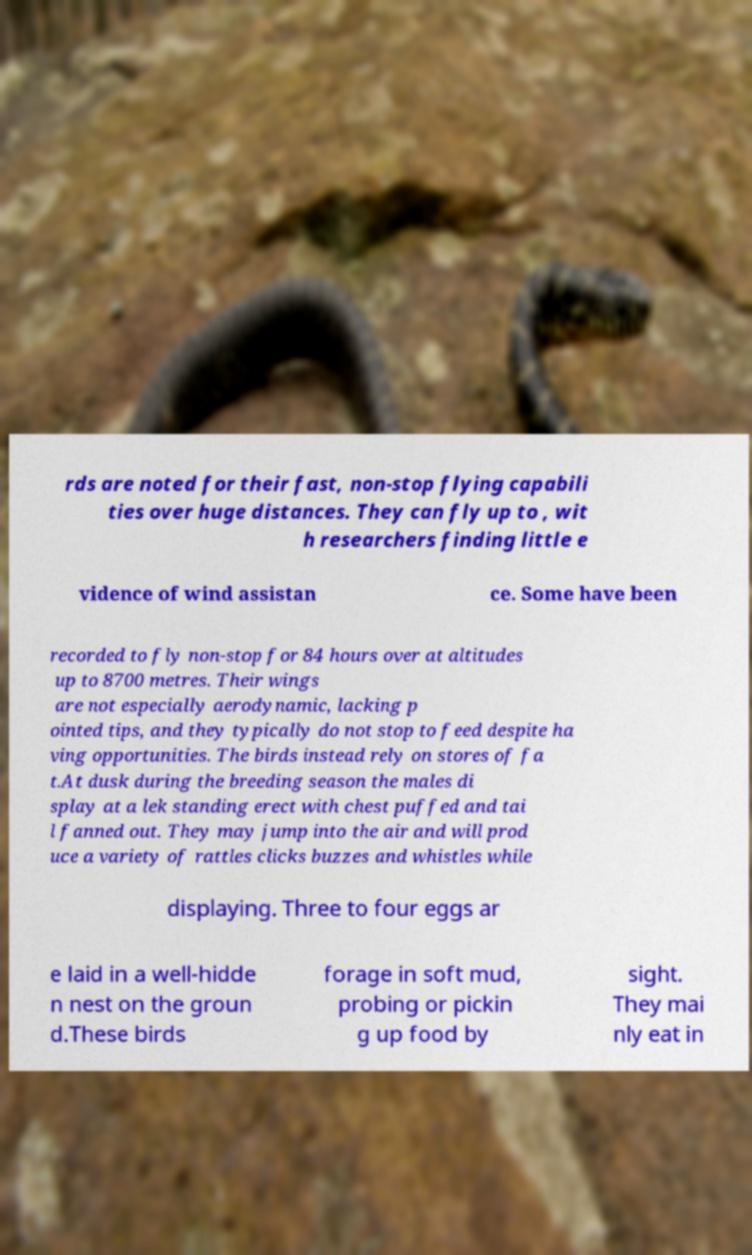There's text embedded in this image that I need extracted. Can you transcribe it verbatim? rds are noted for their fast, non-stop flying capabili ties over huge distances. They can fly up to , wit h researchers finding little e vidence of wind assistan ce. Some have been recorded to fly non-stop for 84 hours over at altitudes up to 8700 metres. Their wings are not especially aerodynamic, lacking p ointed tips, and they typically do not stop to feed despite ha ving opportunities. The birds instead rely on stores of fa t.At dusk during the breeding season the males di splay at a lek standing erect with chest puffed and tai l fanned out. They may jump into the air and will prod uce a variety of rattles clicks buzzes and whistles while displaying. Three to four eggs ar e laid in a well-hidde n nest on the groun d.These birds forage in soft mud, probing or pickin g up food by sight. They mai nly eat in 